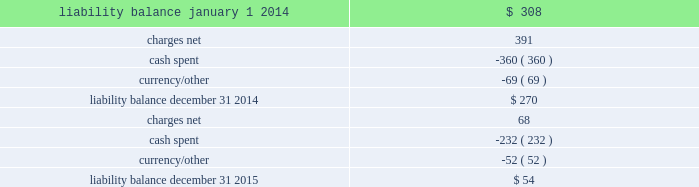Movement in exit cost liabilities the movement in exit cost liabilities for pmi was as follows : ( in millions ) .
Cash payments related to exit costs at pmi were $ 232 million , $ 360 million and $ 21 million for the years ended december 31 , 2015 , 2014 and 2013 , respectively .
Future cash payments for exit costs incurred to date are expected to be approximately $ 54 million , and will be substantially paid by the end of 2017 .
The pre-tax asset impairment and exit costs shown above are primarily a result of the following : the netherlands on april 4 , 2014 , pmi announced the initiation by its affiliate , philip morris holland b.v .
( 201cpmh 201d ) , of consultations with employee representatives on a proposal to discontinue cigarette production at its factory located in bergen op zoom , the netherlands .
Pmh reached an agreement with the trade unions and their members on a social plan and ceased cigarette production on september 1 , 2014 .
During 2014 , total pre-tax asset impairment and exit costs of $ 489 million were recorded for this program in the european union segment .
This amount includes employee separation costs of $ 343 million , asset impairment costs of $ 139 million and other separation costs of $ 7 million .
Separation program charges pmi recorded other pre-tax separation program charges of $ 68 million , $ 41 million and $ 51 million for the years ended december 31 , 2015 , 2014 and 2013 , respectively .
The 2015 other pre-tax separation program charges primarily related to severance costs for the organizational restructuring in the european union segment .
The 2014 other pre-tax separation program charges primarily related to severance costs for factory closures in australia and canada and the restructuring of the u.s .
Leaf purchasing model .
The 2013 pre-tax separation program charges primarily related to the restructuring of global and regional functions based in switzerland and australia .
Contract termination charges during 2013 , pmi recorded exit costs of $ 258 million related to the termination of distribution agreements in eastern europe , middle east & africa ( due to a new business model in egypt ) and asia .
Asset impairment charges during 2014 , pmi recorded other pre-tax asset impairment charges of $ 5 million related to a factory closure in canada. .
What was the difference in cash payments related to exit costs at pmi from 2013 to 2014 in millions? 
Computations: (360 - 21)
Answer: 339.0. 